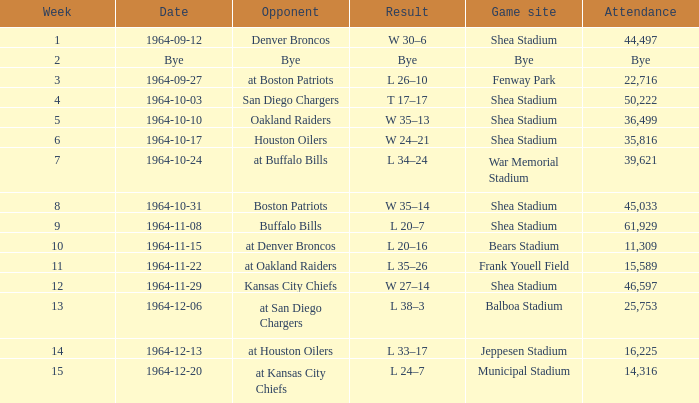Where did the Jet's play with an attendance of 11,309? Bears Stadium. 